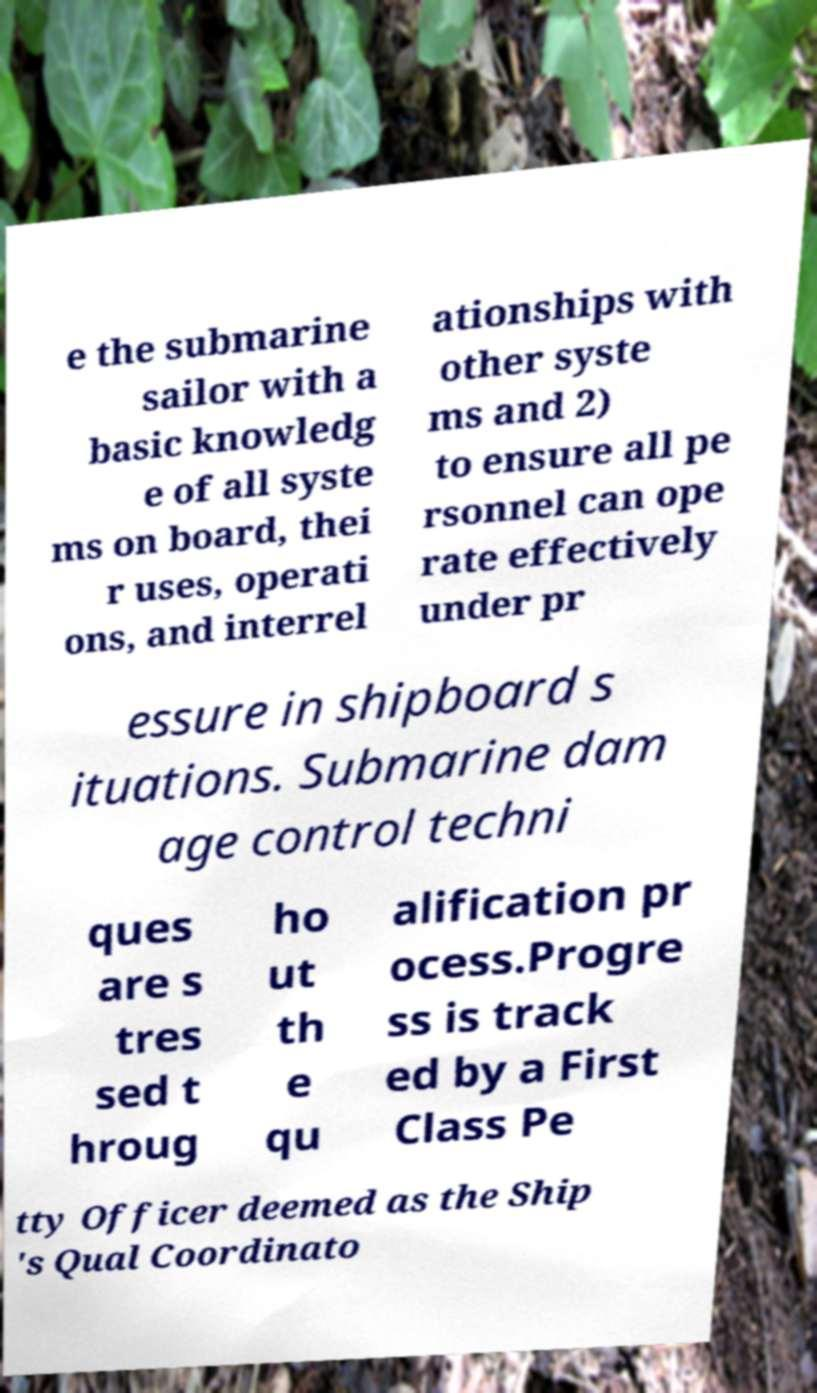Can you read and provide the text displayed in the image?This photo seems to have some interesting text. Can you extract and type it out for me? e the submarine sailor with a basic knowledg e of all syste ms on board, thei r uses, operati ons, and interrel ationships with other syste ms and 2) to ensure all pe rsonnel can ope rate effectively under pr essure in shipboard s ituations. Submarine dam age control techni ques are s tres sed t hroug ho ut th e qu alification pr ocess.Progre ss is track ed by a First Class Pe tty Officer deemed as the Ship 's Qual Coordinato 